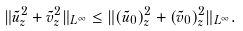Convert formula to latex. <formula><loc_0><loc_0><loc_500><loc_500>\| \tilde { u } _ { z } ^ { 2 } + \tilde { v } _ { z } ^ { 2 } \| _ { L ^ { \infty } } \leq \| ( \tilde { u } _ { 0 } ) _ { z } ^ { 2 } + ( \tilde { v } _ { 0 } ) _ { z } ^ { 2 } \| _ { L ^ { \infty } } .</formula> 